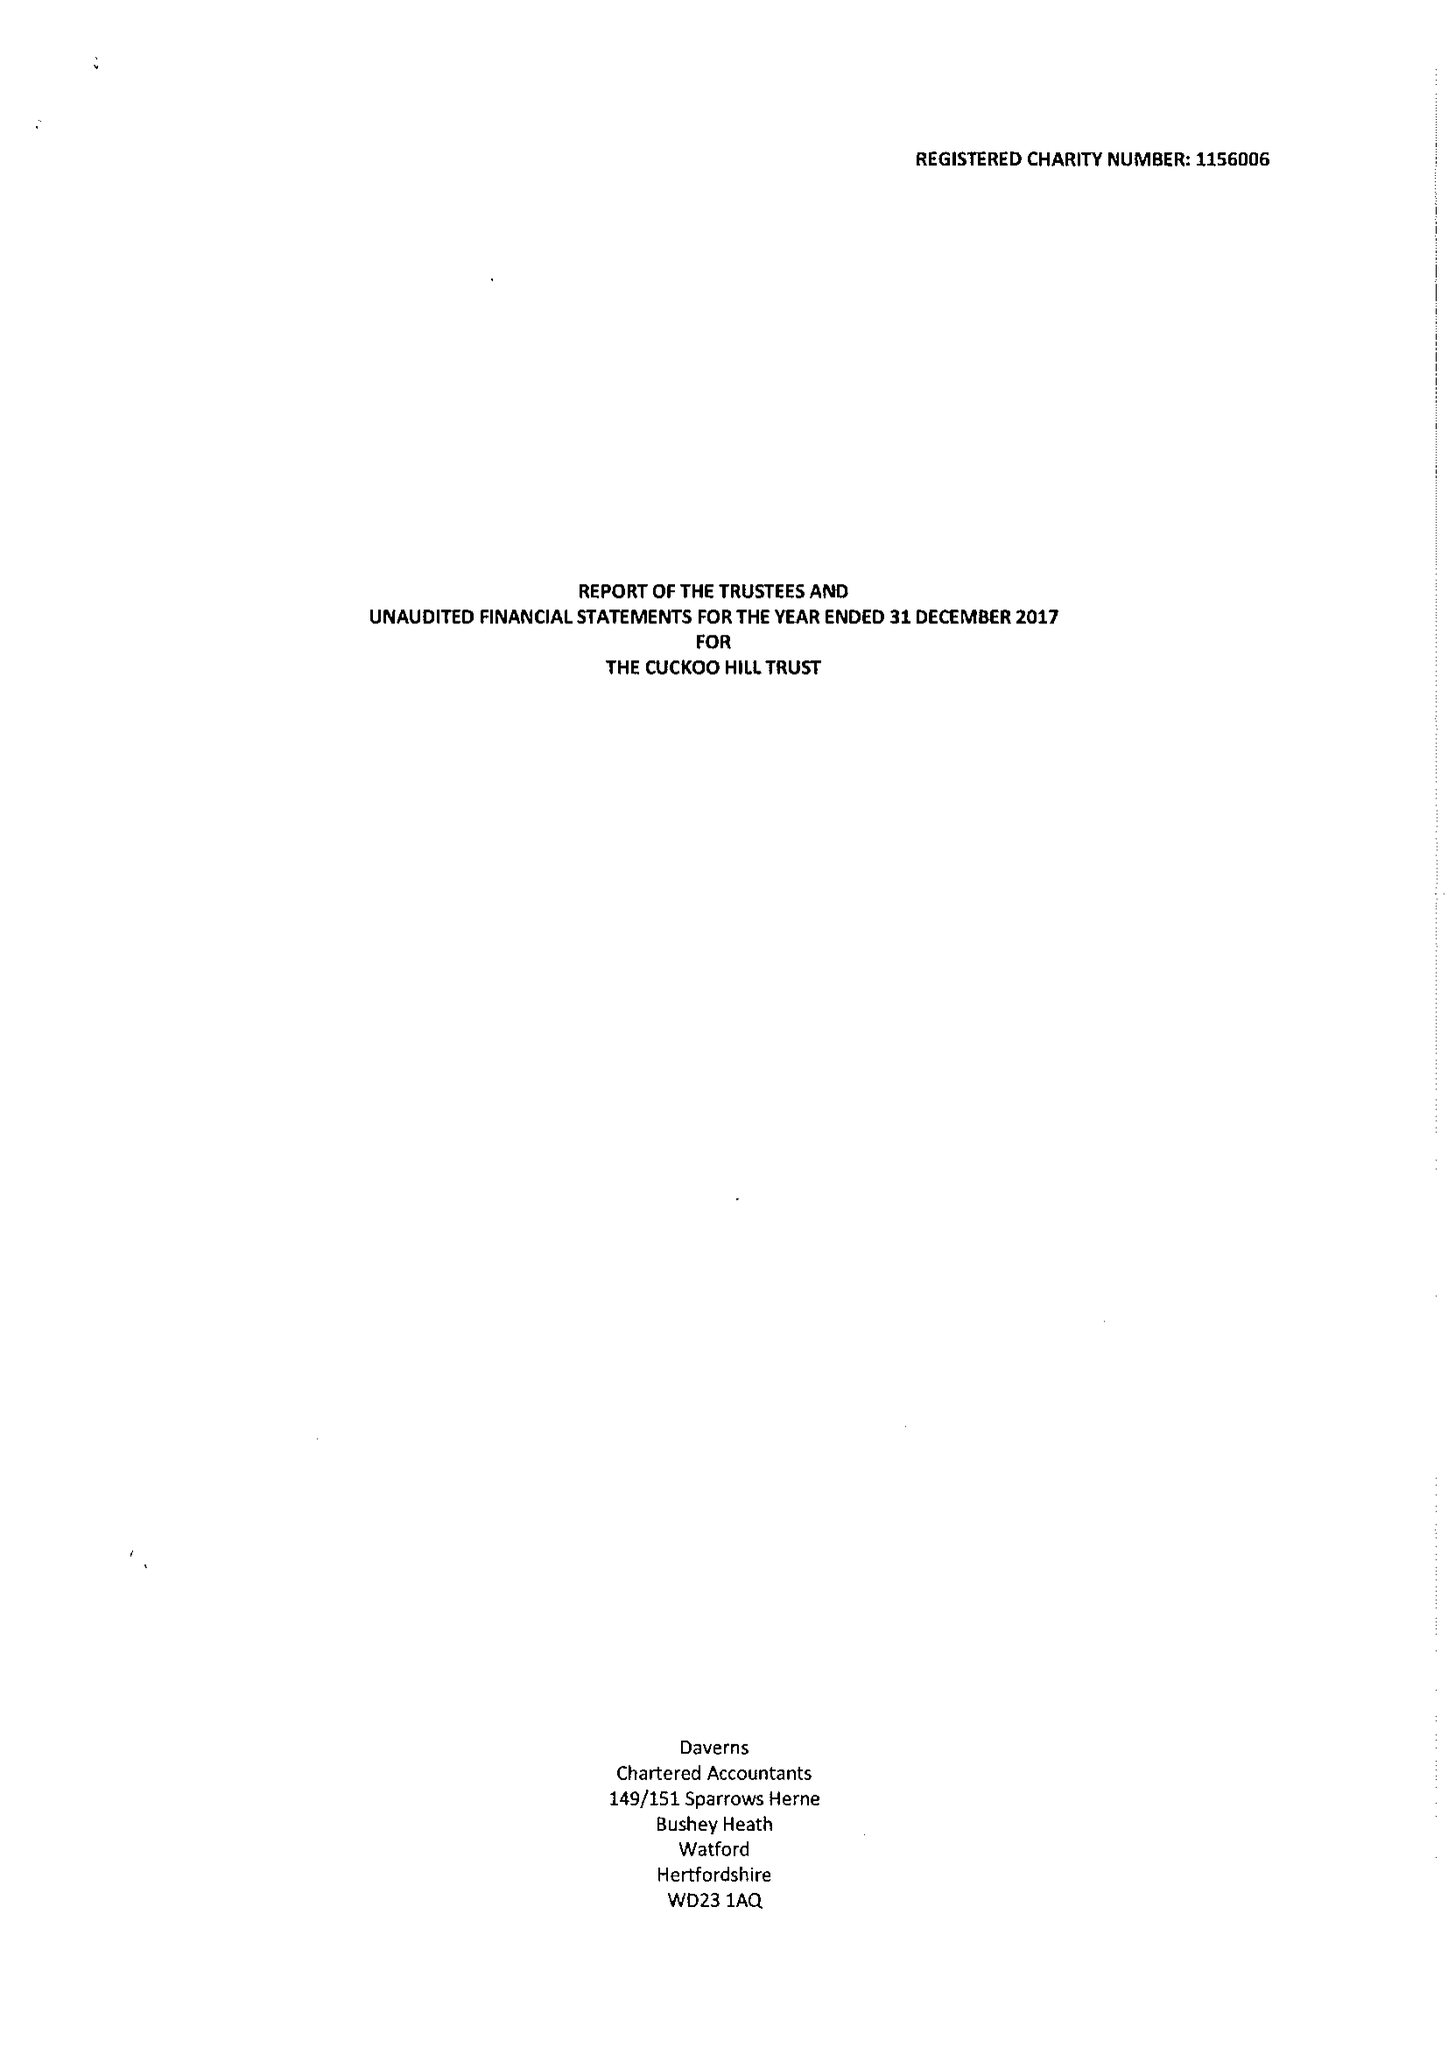What is the value for the address__street_line?
Answer the question using a single word or phrase. CUCKOO HILL 